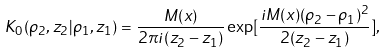<formula> <loc_0><loc_0><loc_500><loc_500>K _ { 0 } ( { \rho _ { 2 } } , z _ { 2 } | { \rho _ { 1 } } , z _ { 1 } ) = \frac { M ( x ) } { 2 \pi i ( z _ { 2 } - z _ { 1 } ) } \exp [ \frac { i M ( x ) ( { \rho _ { 2 } } - { \rho _ { 1 } } ) ^ { 2 } } { 2 ( z _ { 2 } - z _ { 1 } ) } ] ,</formula> 